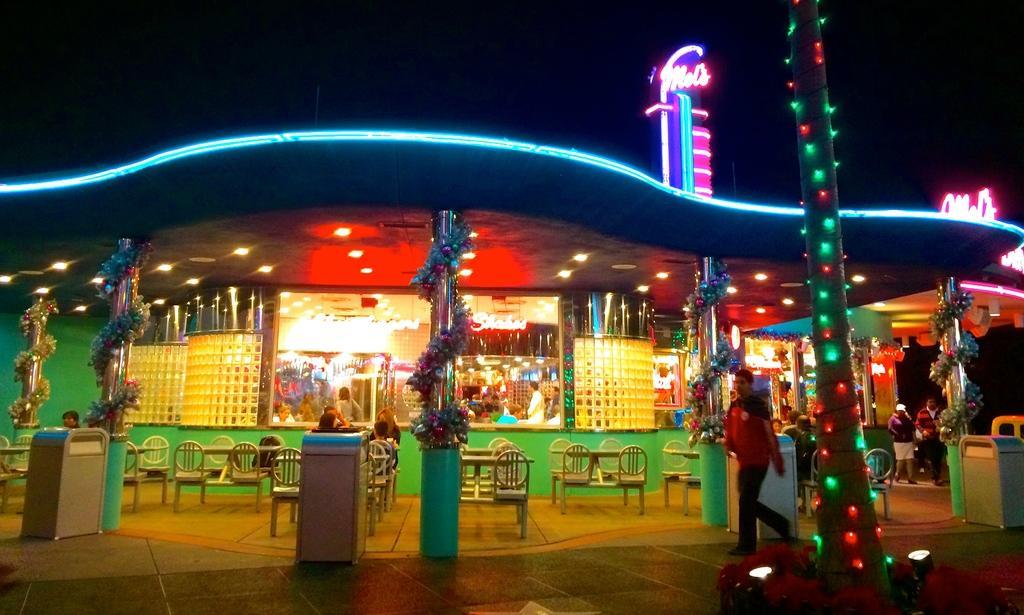Describe this image in one or two sentences. In this picture we can see a place, some people are walking and we can see some chairs, tables are arranged, few people are sitting on the chairs, side we can see some lights and we can see few lights to the trees. 